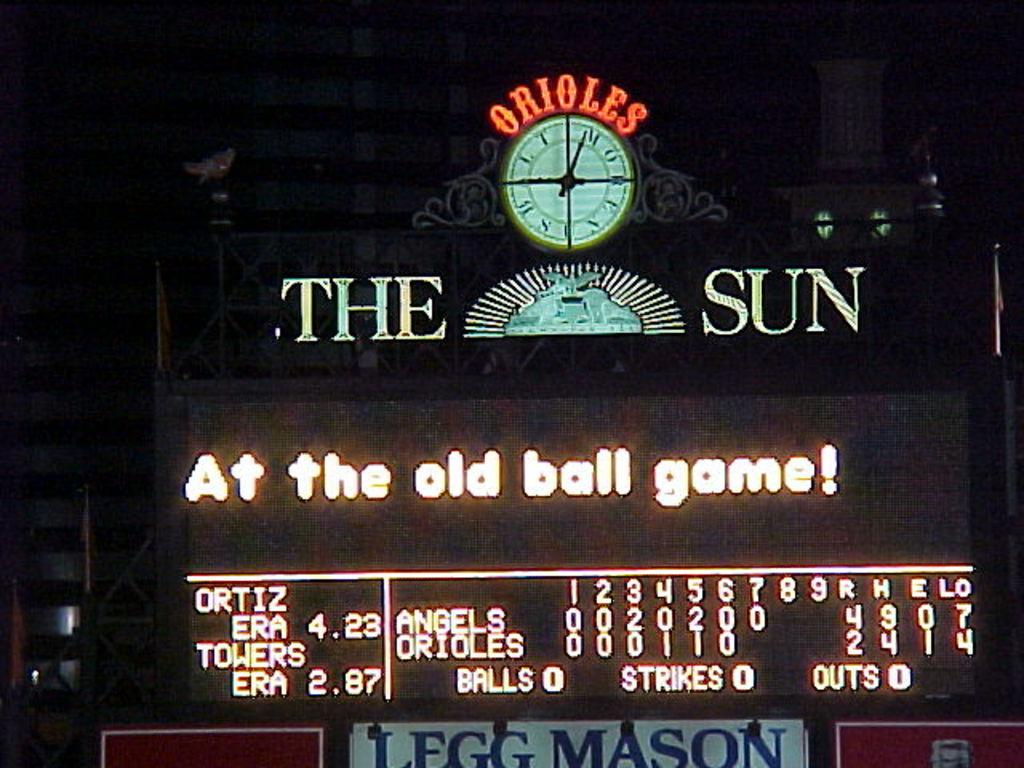<image>
Provide a brief description of the given image. The scoreboard at the Orioles stadium shows the Angels leading the Orioles in runs. 